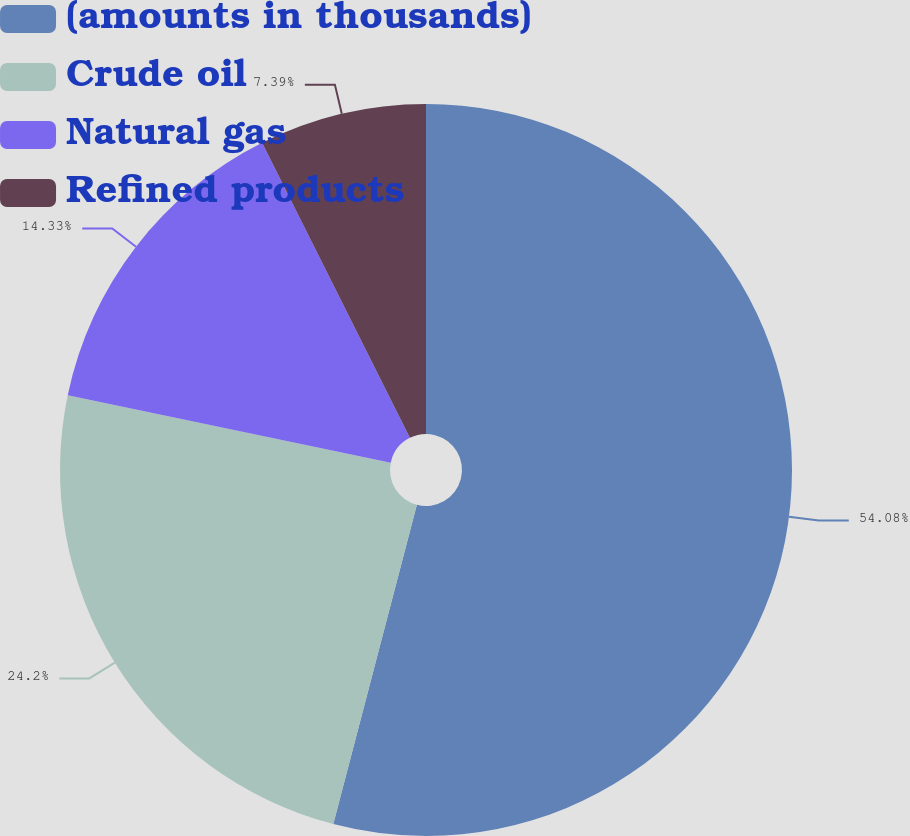<chart> <loc_0><loc_0><loc_500><loc_500><pie_chart><fcel>(amounts in thousands)<fcel>Crude oil<fcel>Natural gas<fcel>Refined products<nl><fcel>54.07%<fcel>24.2%<fcel>14.33%<fcel>7.39%<nl></chart> 